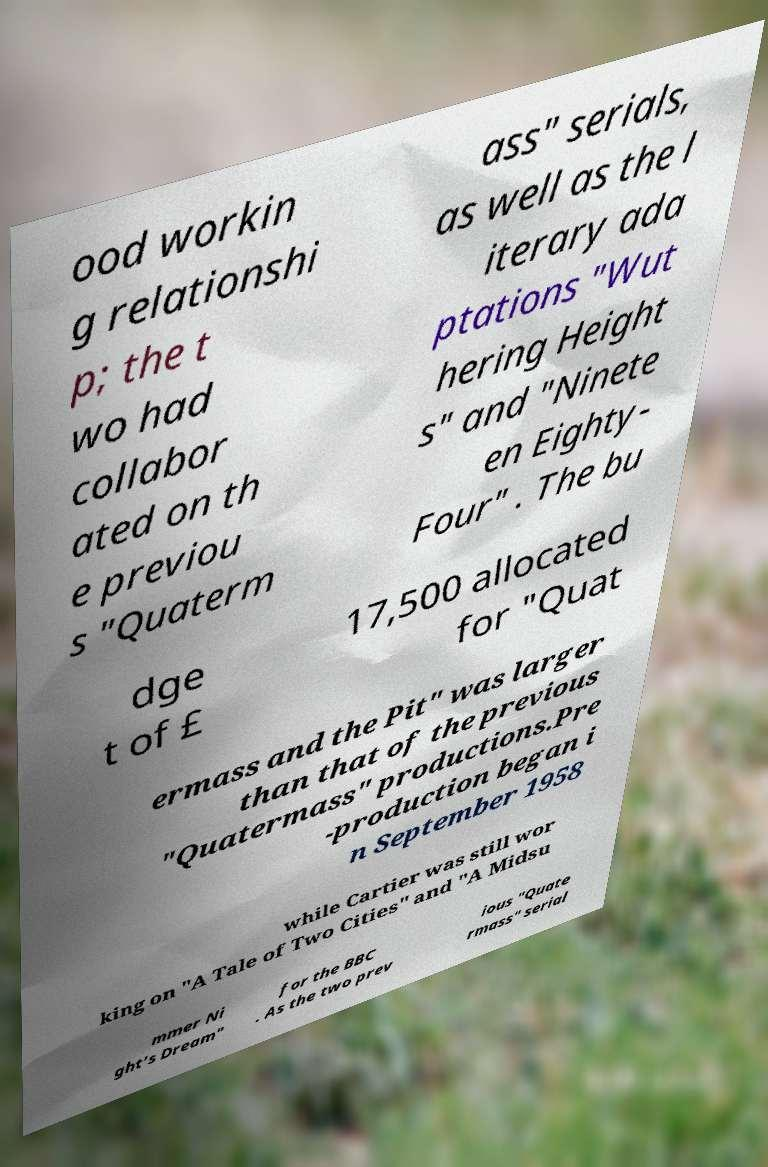There's text embedded in this image that I need extracted. Can you transcribe it verbatim? ood workin g relationshi p; the t wo had collabor ated on th e previou s "Quaterm ass" serials, as well as the l iterary ada ptations "Wut hering Height s" and "Ninete en Eighty- Four" . The bu dge t of £ 17,500 allocated for "Quat ermass and the Pit" was larger than that of the previous "Quatermass" productions.Pre -production began i n September 1958 while Cartier was still wor king on "A Tale of Two Cities" and "A Midsu mmer Ni ght's Dream" for the BBC . As the two prev ious "Quate rmass" serial 